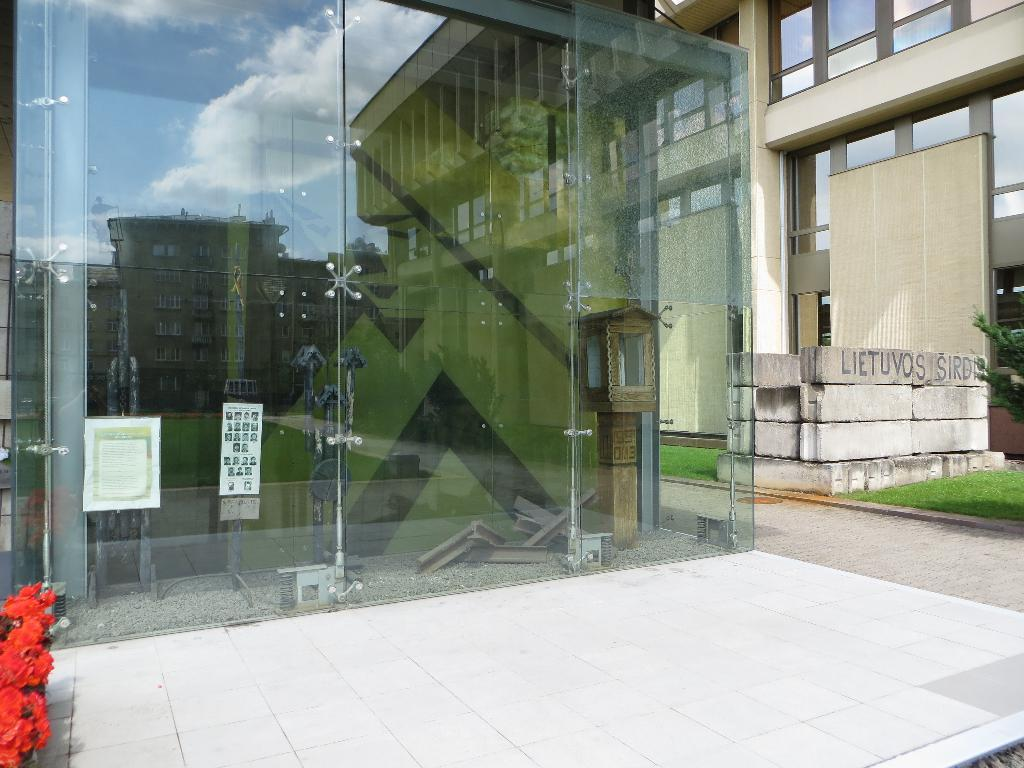What type of wall is present in the image? There is a glass wall in the image. What structure can be seen in the image? There is a building in the image. What feature is present on the building? The building has windows. What type of vegetation is visible in the image? There are flowers and grass in the image. What type of path is present in the image? There is a footpath in the image. What can be seen in the reflection on the glass wall? The sky is visible in the reflection on the glass wall. What type of lunch is being served in the image? There is no lunch present in the image. What type of bird can be seen flying in the image? There are no birds visible in the image. 